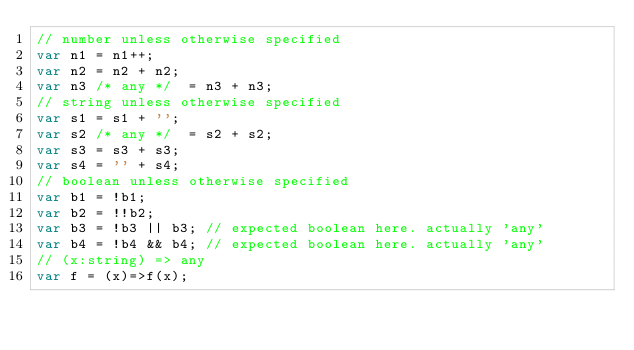Convert code to text. <code><loc_0><loc_0><loc_500><loc_500><_JavaScript_>// number unless otherwise specified
var n1 = n1++;
var n2 = n2 + n2;
var n3 /* any */  = n3 + n3;
// string unless otherwise specified
var s1 = s1 + '';
var s2 /* any */  = s2 + s2;
var s3 = s3 + s3;
var s4 = '' + s4;
// boolean unless otherwise specified
var b1 = !b1;
var b2 = !!b2;
var b3 = !b3 || b3; // expected boolean here. actually 'any'
var b4 = !b4 && b4; // expected boolean here. actually 'any'
// (x:string) => any
var f = (x)=>f(x);
</code> 